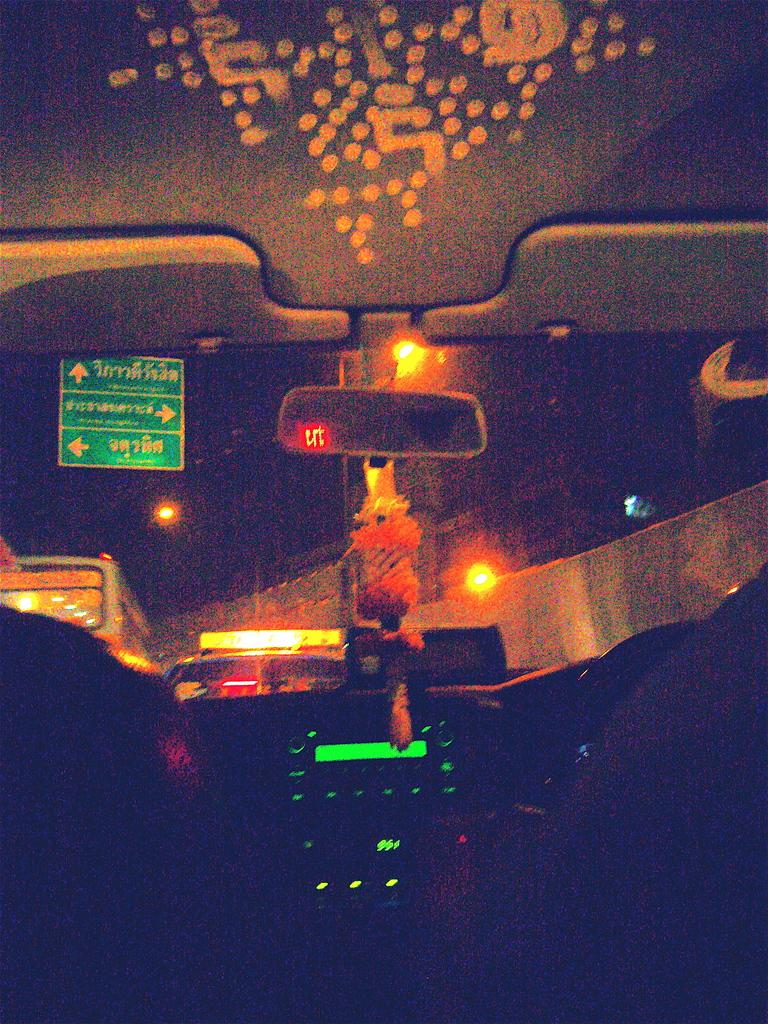What type of setting is depicted in the image? The image shows the interior of a vehicle. What object is used for reflection in the image? There is a mirror in the image. What type of signage can be seen in the image? Green sign boards are present in the image. What can be used for illumination in the image? Lights are visible in the image. How would you describe the lighting conditions in the image? The background of the image is dark. How many spiders are crawling on the comb in the image? There is no comb or spiders present in the image. What type of fly can be seen buzzing around the lights in the image? There are no flies present in the image; only lights are visible. 